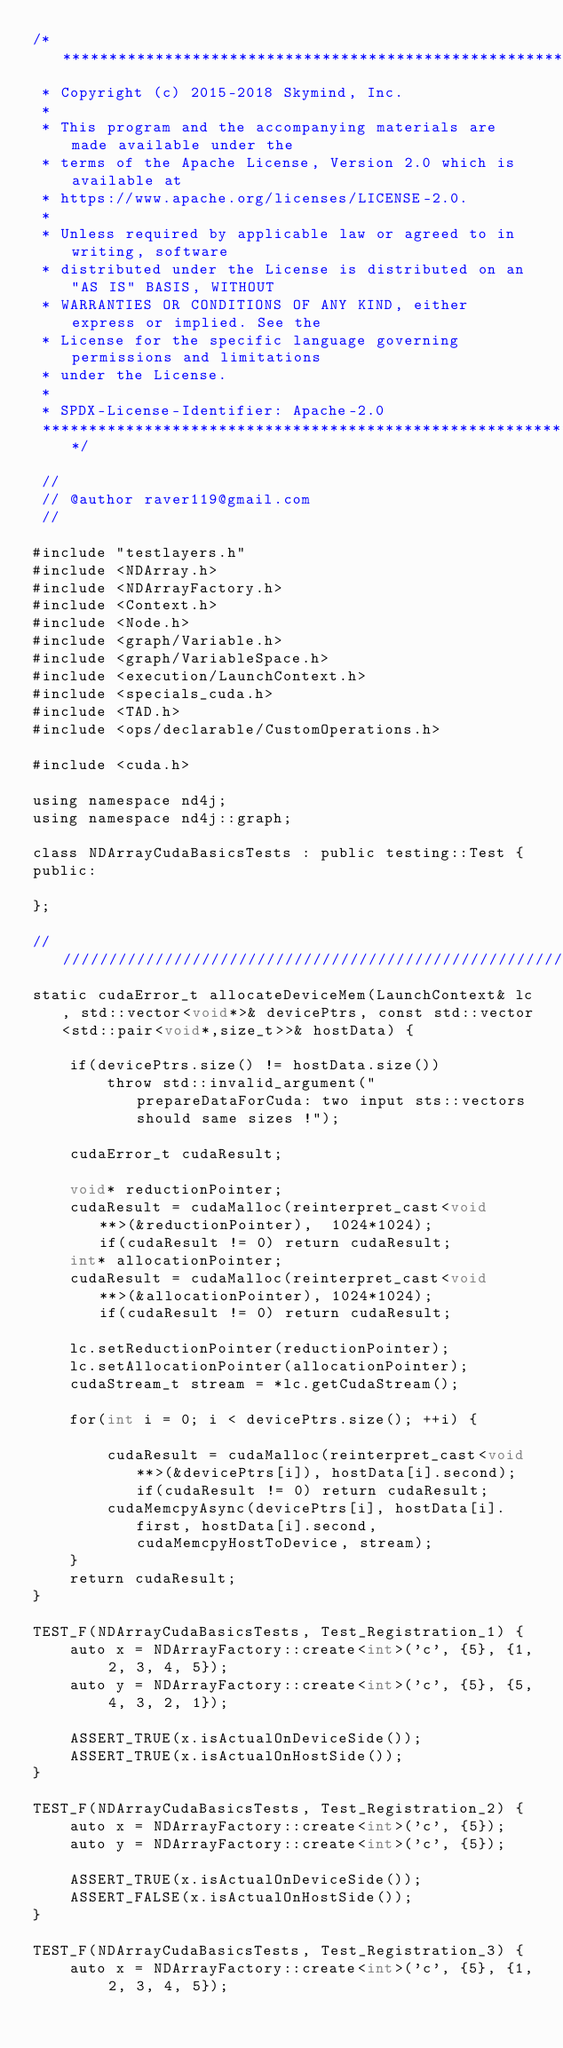<code> <loc_0><loc_0><loc_500><loc_500><_Cuda_>/*******************************************************************************
 * Copyright (c) 2015-2018 Skymind, Inc.
 *
 * This program and the accompanying materials are made available under the
 * terms of the Apache License, Version 2.0 which is available at
 * https://www.apache.org/licenses/LICENSE-2.0.
 *
 * Unless required by applicable law or agreed to in writing, software
 * distributed under the License is distributed on an "AS IS" BASIS, WITHOUT
 * WARRANTIES OR CONDITIONS OF ANY KIND, either express or implied. See the
 * License for the specific language governing permissions and limitations
 * under the License.
 *
 * SPDX-License-Identifier: Apache-2.0
 ******************************************************************************/

 //
 // @author raver119@gmail.com
 //

#include "testlayers.h"
#include <NDArray.h>
#include <NDArrayFactory.h>
#include <Context.h>
#include <Node.h>
#include <graph/Variable.h>
#include <graph/VariableSpace.h>
#include <execution/LaunchContext.h>
#include <specials_cuda.h>
#include <TAD.h>
#include <ops/declarable/CustomOperations.h>

#include <cuda.h>

using namespace nd4j;
using namespace nd4j::graph;

class NDArrayCudaBasicsTests : public testing::Test {
public:

};

//////////////////////////////////////////////////////////////////////////
static cudaError_t allocateDeviceMem(LaunchContext& lc, std::vector<void*>& devicePtrs, const std::vector<std::pair<void*,size_t>>& hostData) {

    if(devicePtrs.size() != hostData.size())
        throw std::invalid_argument("prepareDataForCuda: two input sts::vectors should same sizes !");

    cudaError_t cudaResult;

    void* reductionPointer;
    cudaResult = cudaMalloc(reinterpret_cast<void **>(&reductionPointer),  1024*1024);			if(cudaResult != 0) return cudaResult;
    int* allocationPointer;
    cudaResult = cudaMalloc(reinterpret_cast<void **>(&allocationPointer), 1024*1024);			if(cudaResult != 0) return cudaResult;

    lc.setReductionPointer(reductionPointer);
    lc.setAllocationPointer(allocationPointer);
    cudaStream_t stream = *lc.getCudaStream();

    for(int i = 0; i < devicePtrs.size(); ++i) {

        cudaResult = cudaMalloc(reinterpret_cast<void **>(&devicePtrs[i]), hostData[i].second); if(cudaResult != 0) return cudaResult;
        cudaMemcpyAsync(devicePtrs[i], hostData[i].first, hostData[i].second, cudaMemcpyHostToDevice, stream);
    }
    return cudaResult;
}

TEST_F(NDArrayCudaBasicsTests, Test_Registration_1) {
    auto x = NDArrayFactory::create<int>('c', {5}, {1, 2, 3, 4, 5});
    auto y = NDArrayFactory::create<int>('c', {5}, {5, 4, 3, 2, 1});

    ASSERT_TRUE(x.isActualOnDeviceSide());
    ASSERT_TRUE(x.isActualOnHostSide());
}

TEST_F(NDArrayCudaBasicsTests, Test_Registration_2) {
    auto x = NDArrayFactory::create<int>('c', {5});
    auto y = NDArrayFactory::create<int>('c', {5});

    ASSERT_TRUE(x.isActualOnDeviceSide());
    ASSERT_FALSE(x.isActualOnHostSide());
}

TEST_F(NDArrayCudaBasicsTests, Test_Registration_3) {
    auto x = NDArrayFactory::create<int>('c', {5}, {1, 2, 3, 4, 5});</code> 